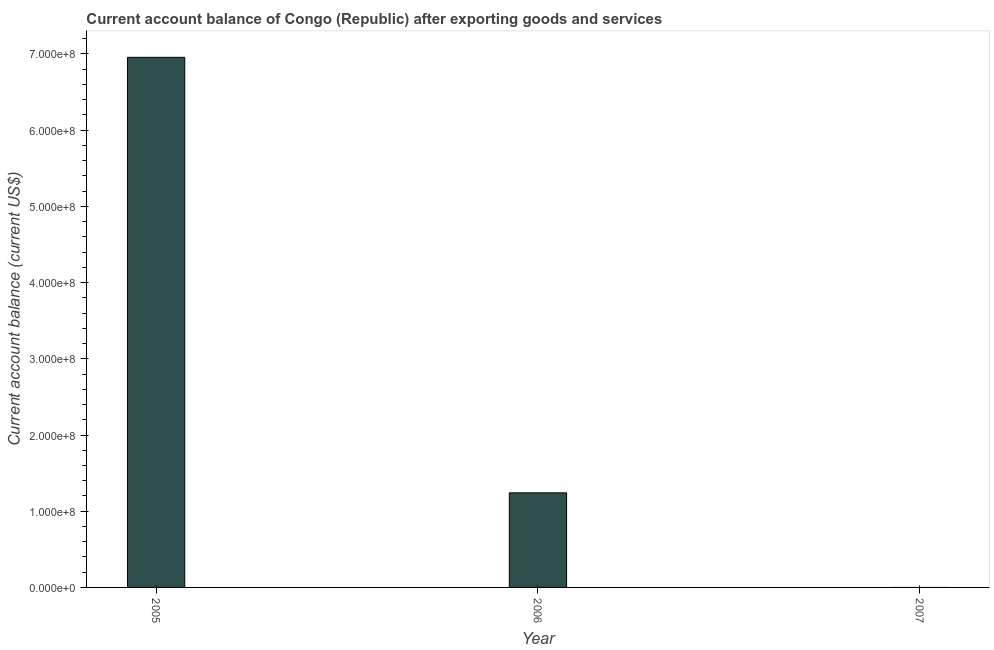Does the graph contain any zero values?
Provide a short and direct response. Yes. Does the graph contain grids?
Your response must be concise. No. What is the title of the graph?
Offer a very short reply. Current account balance of Congo (Republic) after exporting goods and services. What is the label or title of the X-axis?
Offer a terse response. Year. What is the label or title of the Y-axis?
Your answer should be compact. Current account balance (current US$). What is the current account balance in 2005?
Provide a short and direct response. 6.96e+08. Across all years, what is the maximum current account balance?
Your answer should be compact. 6.96e+08. Across all years, what is the minimum current account balance?
Your answer should be compact. 0. In which year was the current account balance maximum?
Your answer should be very brief. 2005. What is the sum of the current account balance?
Keep it short and to the point. 8.20e+08. What is the difference between the current account balance in 2005 and 2006?
Offer a very short reply. 5.71e+08. What is the average current account balance per year?
Your response must be concise. 2.73e+08. What is the median current account balance?
Give a very brief answer. 1.24e+08. In how many years, is the current account balance greater than 200000000 US$?
Offer a terse response. 1. What is the ratio of the current account balance in 2005 to that in 2006?
Offer a terse response. 5.6. Is the difference between the current account balance in 2005 and 2006 greater than the difference between any two years?
Your answer should be very brief. No. What is the difference between the highest and the lowest current account balance?
Ensure brevity in your answer.  6.96e+08. How many years are there in the graph?
Make the answer very short. 3. What is the difference between two consecutive major ticks on the Y-axis?
Offer a very short reply. 1.00e+08. Are the values on the major ticks of Y-axis written in scientific E-notation?
Give a very brief answer. Yes. What is the Current account balance (current US$) in 2005?
Offer a very short reply. 6.96e+08. What is the Current account balance (current US$) of 2006?
Your response must be concise. 1.24e+08. What is the Current account balance (current US$) of 2007?
Keep it short and to the point. 0. What is the difference between the Current account balance (current US$) in 2005 and 2006?
Your response must be concise. 5.71e+08. What is the ratio of the Current account balance (current US$) in 2005 to that in 2006?
Provide a short and direct response. 5.6. 